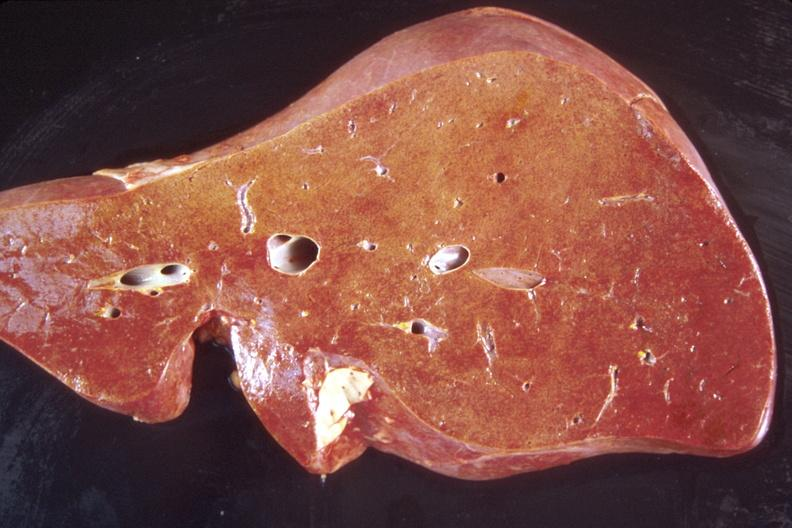s lower chest and abdomen anterior present?
Answer the question using a single word or phrase. No 